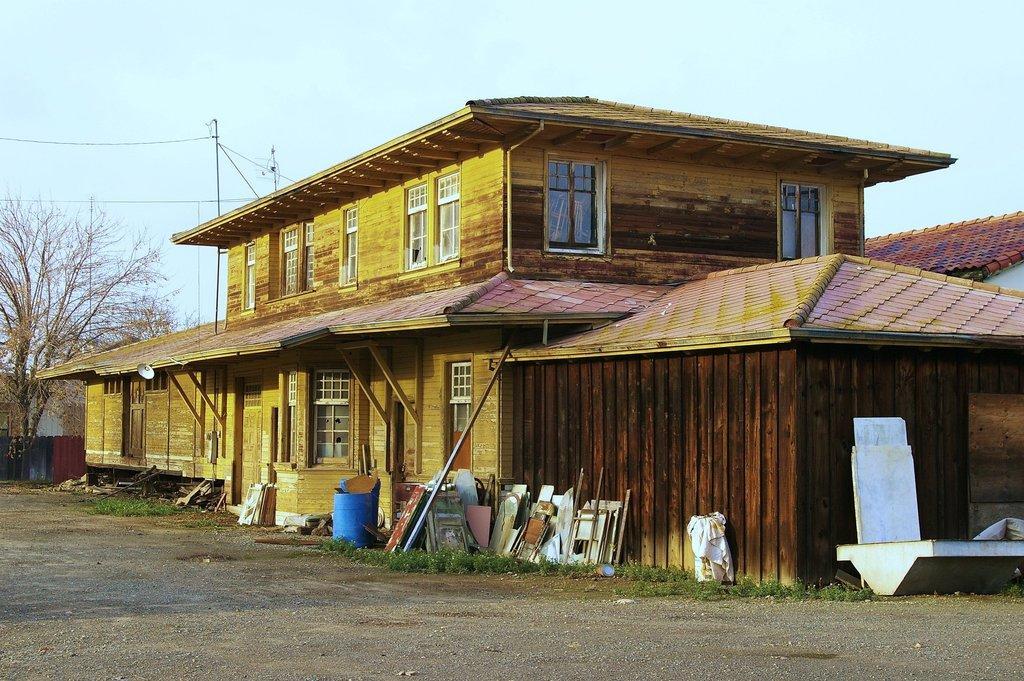Describe this image in one or two sentences. In this image there is a house in middle of this image and there is a drum in blue color at bottom of this image and there is a tree at left side of this image. There are some current poles at top left side of this image and there are some objects kept at bottom of this image and there are some windows at middle of this image. and there is a door at bottom left side of this image. 